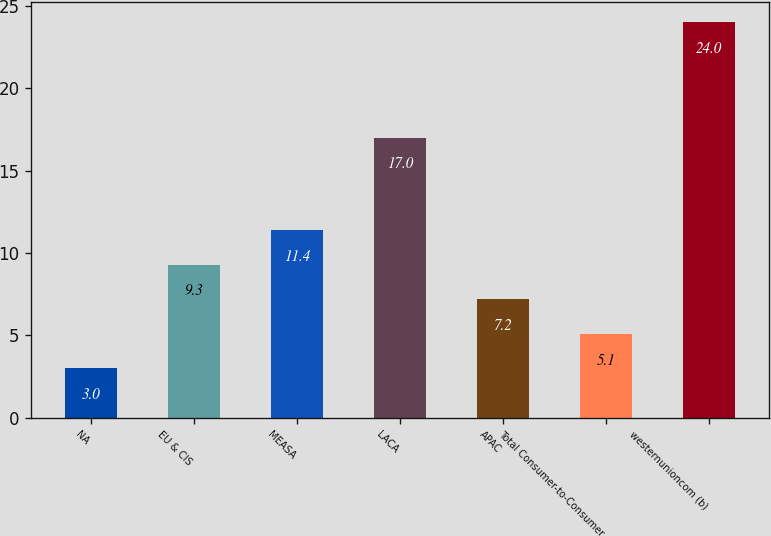Convert chart to OTSL. <chart><loc_0><loc_0><loc_500><loc_500><bar_chart><fcel>NA<fcel>EU & CIS<fcel>MEASA<fcel>LACA<fcel>APAC<fcel>Total Consumer-to-Consumer<fcel>westernunioncom (b)<nl><fcel>3<fcel>9.3<fcel>11.4<fcel>17<fcel>7.2<fcel>5.1<fcel>24<nl></chart> 